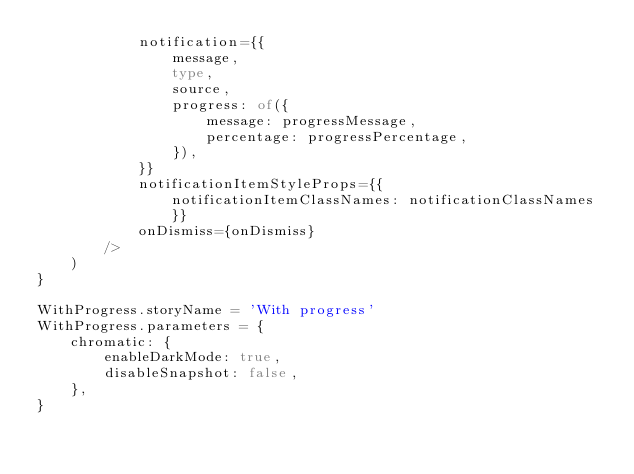Convert code to text. <code><loc_0><loc_0><loc_500><loc_500><_TypeScript_>            notification={{
                message,
                type,
                source,
                progress: of({
                    message: progressMessage,
                    percentage: progressPercentage,
                }),
            }}
            notificationItemStyleProps={{ notificationItemClassNames: notificationClassNames }}
            onDismiss={onDismiss}
        />
    )
}

WithProgress.storyName = 'With progress'
WithProgress.parameters = {
    chromatic: {
        enableDarkMode: true,
        disableSnapshot: false,
    },
}
</code> 